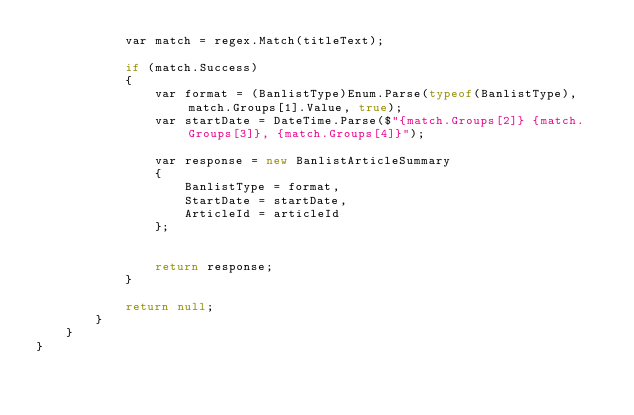<code> <loc_0><loc_0><loc_500><loc_500><_C#_>            var match = regex.Match(titleText);

            if (match.Success)
            {
                var format = (BanlistType)Enum.Parse(typeof(BanlistType), match.Groups[1].Value, true);
                var startDate = DateTime.Parse($"{match.Groups[2]} {match.Groups[3]}, {match.Groups[4]}");

                var response = new BanlistArticleSummary
                {
                    BanlistType = format,
                    StartDate = startDate,
                    ArticleId = articleId
                };


                return response;
            }

            return null;
        }
    }
}</code> 